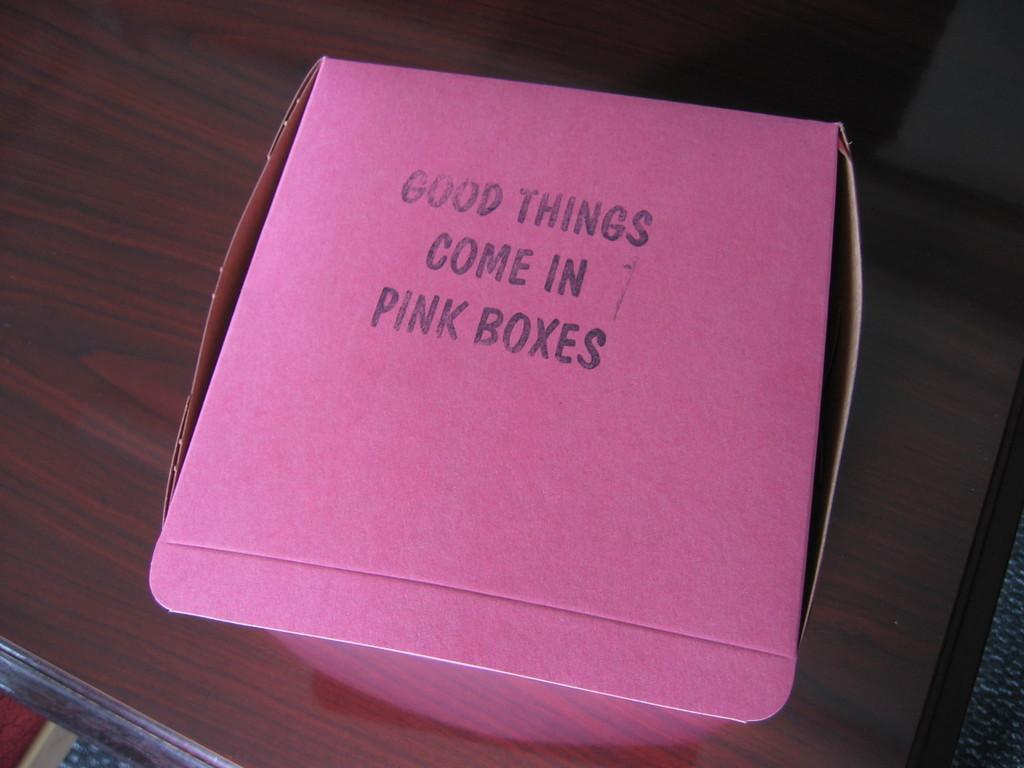What is the main object in the image? There is a cardboard carton in the image. Where is the cardboard carton located? The cardboard carton is placed on a table. What type of answer can be seen written on the cardboard carton in the image? There is no answer written on the cardboard carton in the image. How many giants are visible in the image? There are no giants present in the image. 